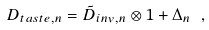<formula> <loc_0><loc_0><loc_500><loc_500>D _ { t a s t e , n } = { \tilde { D } } _ { i n v , n } \otimes { 1 } + \Delta _ { n } \ ,</formula> 